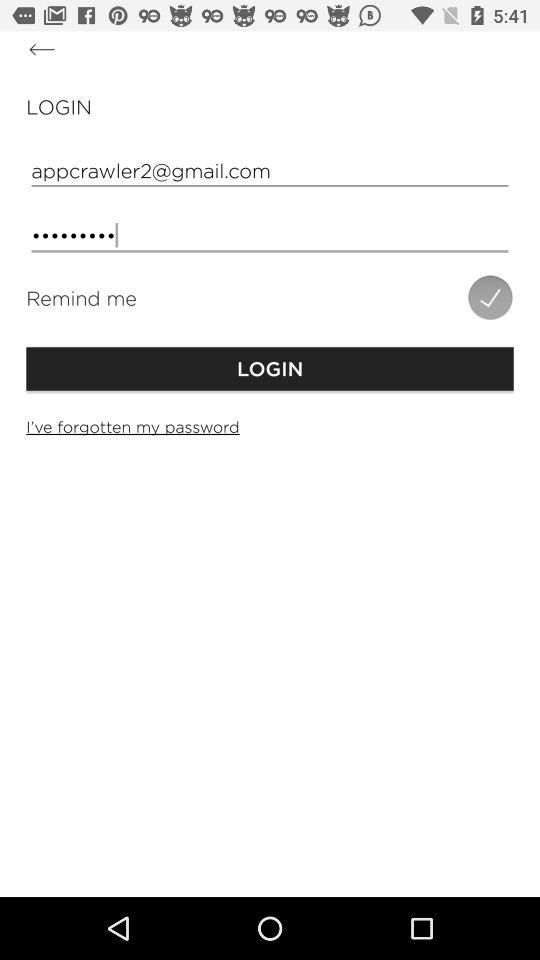What is the status of "Remind me"? The status of "Remind me" is "on". 